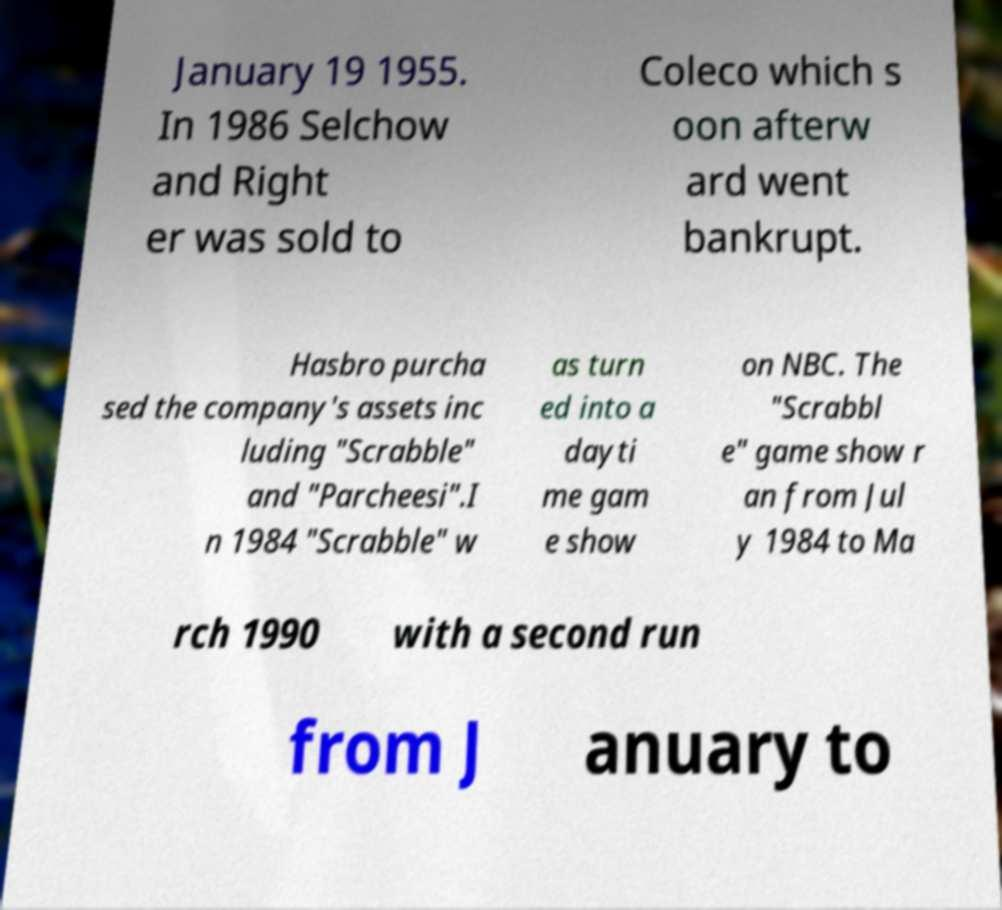For documentation purposes, I need the text within this image transcribed. Could you provide that? January 19 1955. In 1986 Selchow and Right er was sold to Coleco which s oon afterw ard went bankrupt. Hasbro purcha sed the company's assets inc luding "Scrabble" and "Parcheesi".I n 1984 "Scrabble" w as turn ed into a dayti me gam e show on NBC. The "Scrabbl e" game show r an from Jul y 1984 to Ma rch 1990 with a second run from J anuary to 